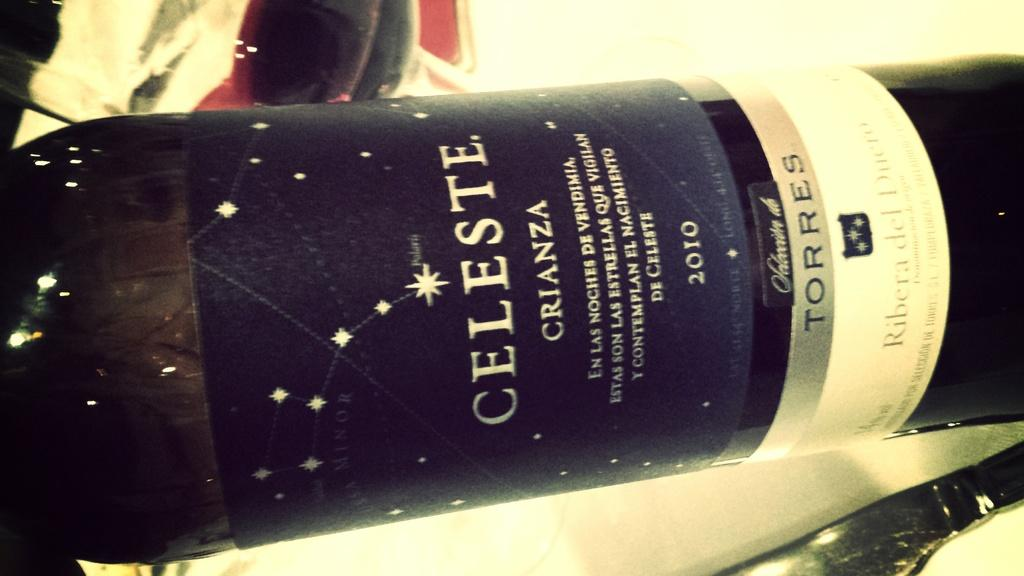<image>
Share a concise interpretation of the image provided. A bottle with a blue label by Celeste. 